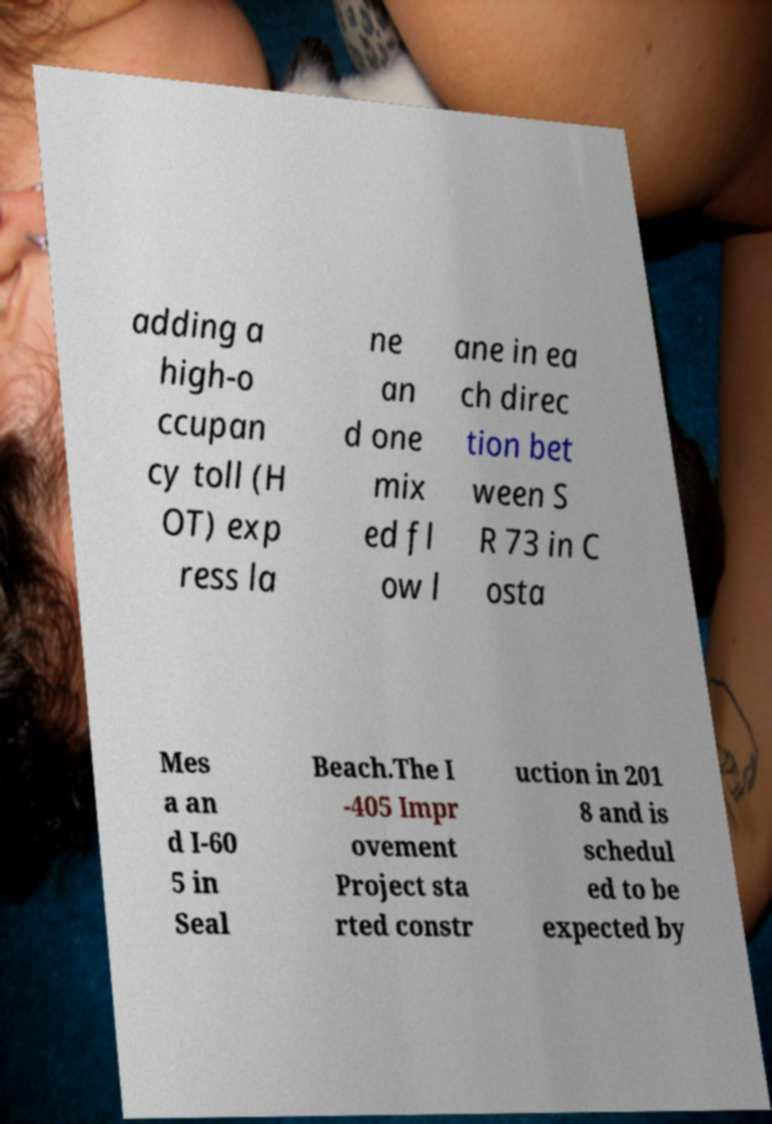Please identify and transcribe the text found in this image. adding a high-o ccupan cy toll (H OT) exp ress la ne an d one mix ed fl ow l ane in ea ch direc tion bet ween S R 73 in C osta Mes a an d I-60 5 in Seal Beach.The I -405 Impr ovement Project sta rted constr uction in 201 8 and is schedul ed to be expected by 